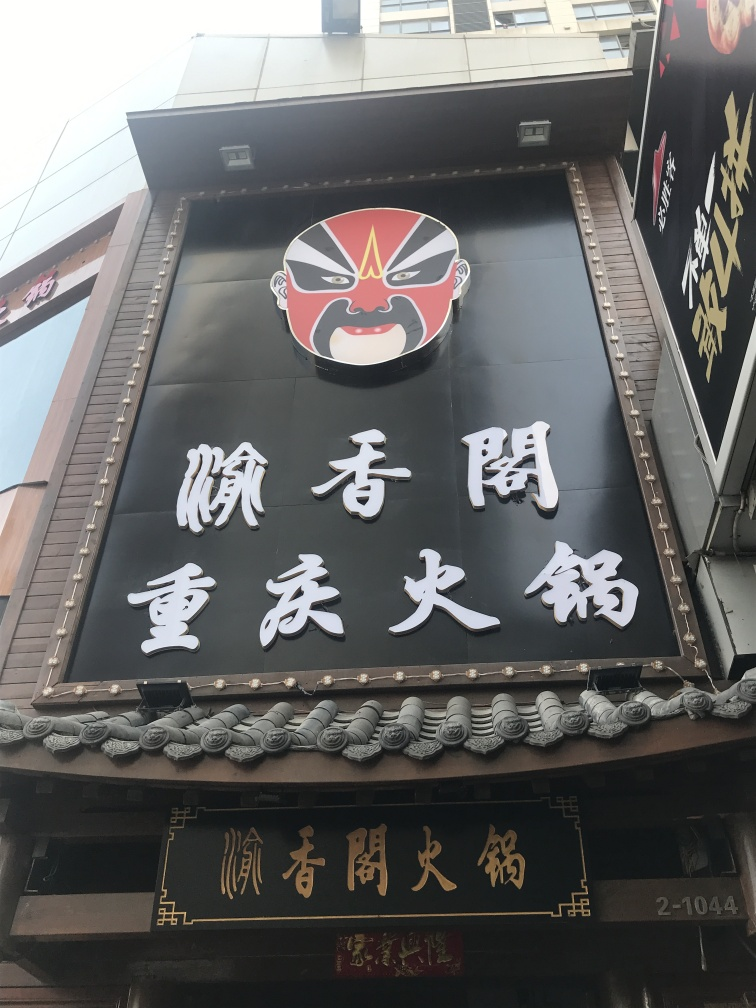Could you explain the significance of the mask on the sign? The mask depicted on the sign is a hallmark of traditional Japanese theater, often used in Noh, Kabuki, and other performing arts to represent characters, emotions, and social roles. Its inclusion on the sign hints at the establishment's cultural roots and possibly the type of service or entertainment offered inside, aligning with the customs and storytelling techniques of Japanese performative arts. 